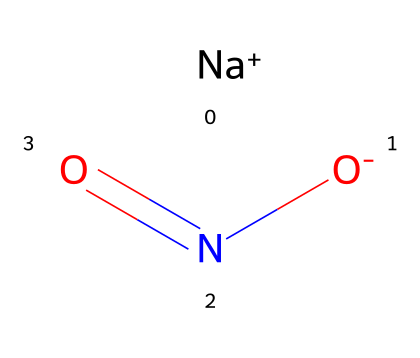What is the molecular formula of this chemical? The chemical is represented by the SMILES notation which indicates the presence of sodium, nitrogen, and oxygen atoms. By counting the components, we see there is one sodium (Na), one nitrogen (N), and two oxygen (O) atoms. Thus, the molecular formula is NaNO2.
Answer: NaNO2 How many nitrogen atoms are present in this molecule? Looking at the SMILES representation, we only see one nitrogen atom denoted by 'N'. Therefore, the total count is one.
Answer: one What type of bond is present between nitrogen and oxygen? In the chemical structure, the nitrogen is connected to oxygen with a double bond, as indicated by the '=' symbol in the SMILES notation.
Answer: double bond What role does this chemical play in food preservation? This chemical is commonly used as a preservative to prevent microbial growth and improve shelf-life in cured meats, which is primarily due to its ability to inhibit the growth of bacteria.
Answer: preservative Is this chemical ionic or covalent? This chemical has sodium, which is a metal, indicating an ionic character, while the nitrogen and oxygen atoms are bonded covalently. However, overall, it is classified as ionic due to the presence of the sodium ion.
Answer: ionic What is a potential risk associated with the consumption of nitrites? Nitrites can react with amines to form nitrosamines, which are potential carcinogens. This is a health concern when consuming processed meats that contain nitrites.
Answer: carcinogenic 